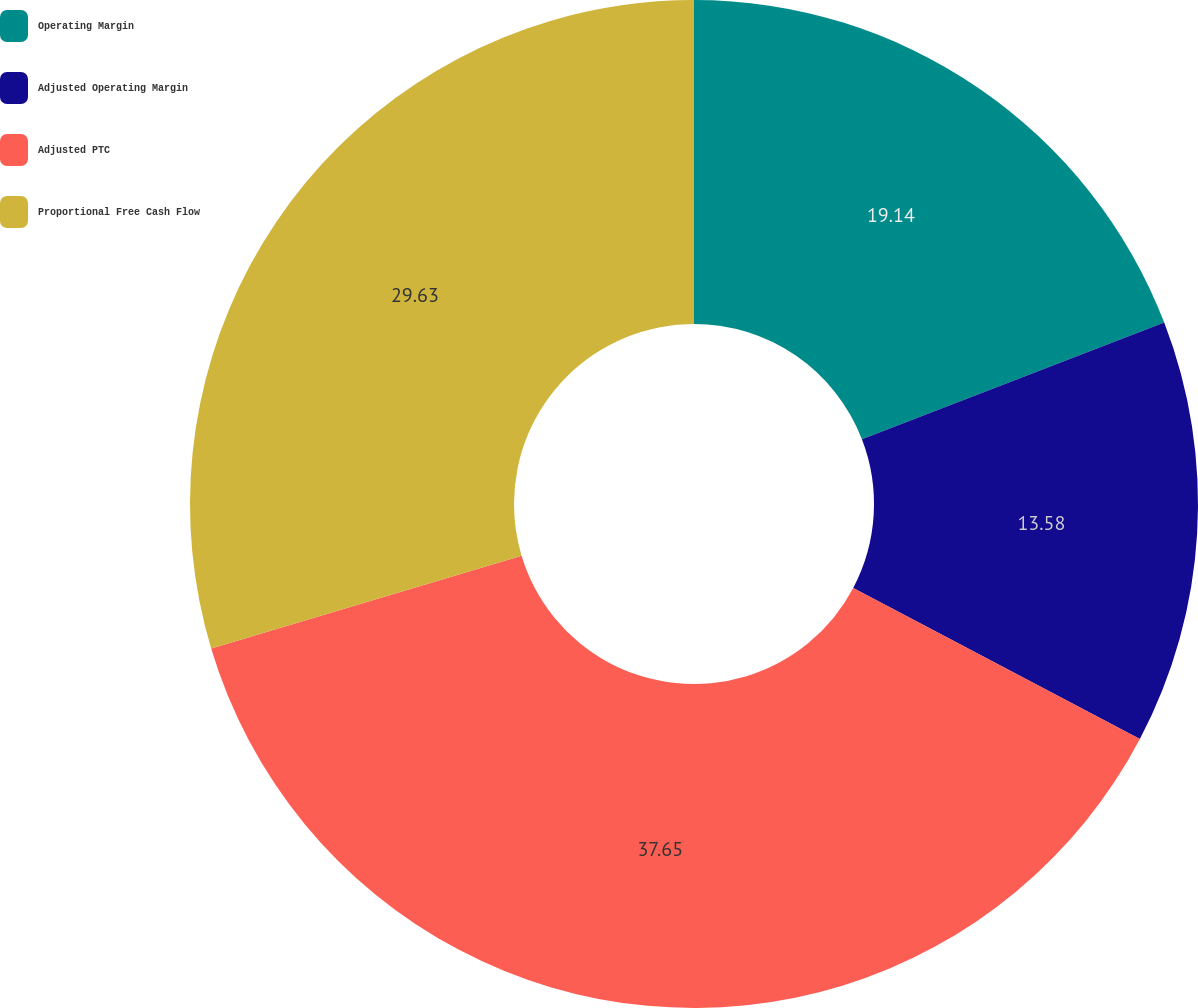Convert chart. <chart><loc_0><loc_0><loc_500><loc_500><pie_chart><fcel>Operating Margin<fcel>Adjusted Operating Margin<fcel>Adjusted PTC<fcel>Proportional Free Cash Flow<nl><fcel>19.14%<fcel>13.58%<fcel>37.65%<fcel>29.63%<nl></chart> 